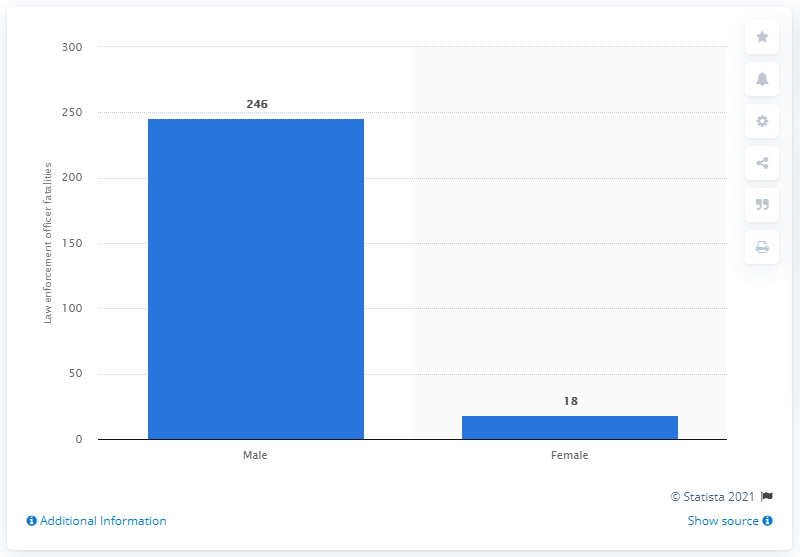Draw attention to some important aspects in this diagram. In 2020, a total of 246 male law enforcement officers lost their lives while performing their duties in the United States. 